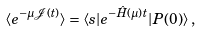Convert formula to latex. <formula><loc_0><loc_0><loc_500><loc_500>\langle e ^ { - \mu \mathcal { J } ( t ) } \rangle = \langle s | e ^ { - \hat { H } ( \mu ) t } | P ( 0 ) \rangle \, ,</formula> 